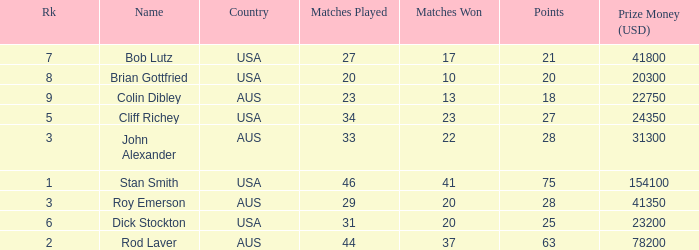How many matches did the player that played 23 matches win 13.0. Can you parse all the data within this table? {'header': ['Rk', 'Name', 'Country', 'Matches Played', 'Matches Won', 'Points', 'Prize Money (USD)'], 'rows': [['7', 'Bob Lutz', 'USA', '27', '17', '21', '41800'], ['8', 'Brian Gottfried', 'USA', '20', '10', '20', '20300'], ['9', 'Colin Dibley', 'AUS', '23', '13', '18', '22750'], ['5', 'Cliff Richey', 'USA', '34', '23', '27', '24350'], ['3', 'John Alexander', 'AUS', '33', '22', '28', '31300'], ['1', 'Stan Smith', 'USA', '46', '41', '75', '154100'], ['3', 'Roy Emerson', 'AUS', '29', '20', '28', '41350'], ['6', 'Dick Stockton', 'USA', '31', '20', '25', '23200'], ['2', 'Rod Laver', 'AUS', '44', '37', '63', '78200']]} 